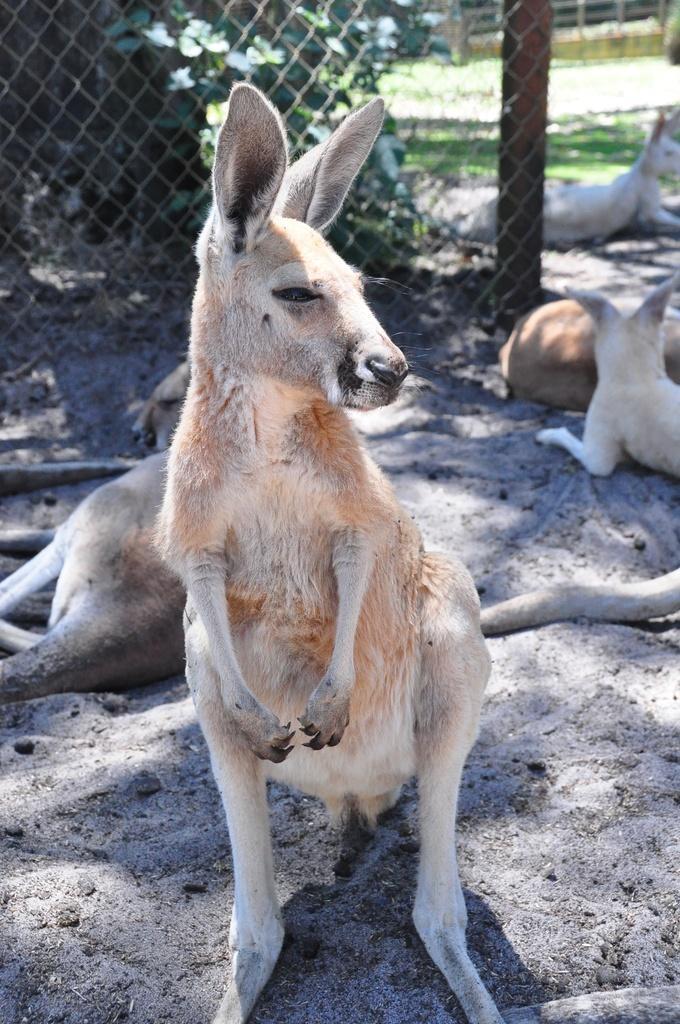Please provide a concise description of this image. In this image there a few animals sitting on the ground. In the foreground there is a kangaroo standing on the ground. Behind them there is a fencing. Behind the fencing there are plants and grass on the ground. 